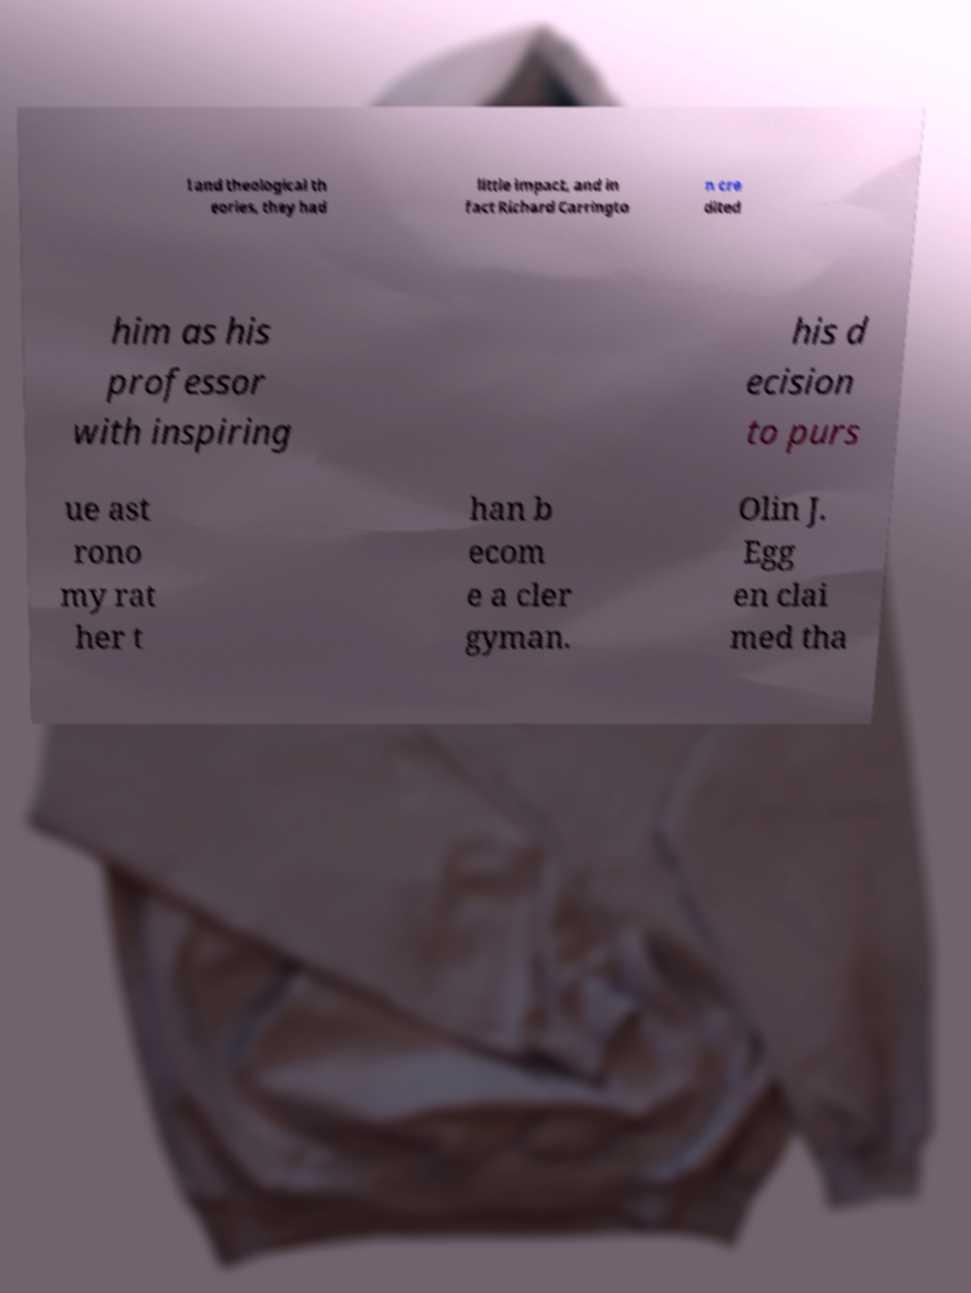There's text embedded in this image that I need extracted. Can you transcribe it verbatim? l and theological th eories, they had little impact, and in fact Richard Carringto n cre dited him as his professor with inspiring his d ecision to purs ue ast rono my rat her t han b ecom e a cler gyman. Olin J. Egg en clai med tha 